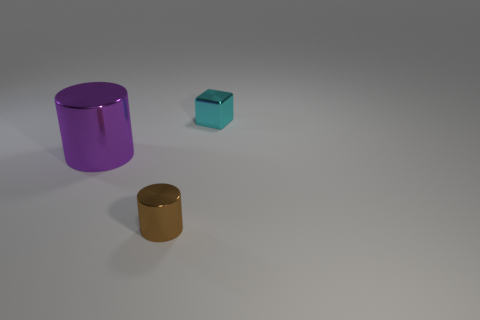What number of cyan blocks are there?
Keep it short and to the point. 1. Is the size of the block that is behind the brown cylinder the same as the small shiny cylinder?
Provide a short and direct response. Yes. What number of metallic objects are either cylinders or purple cylinders?
Provide a succinct answer. 2. How many small metal objects are to the right of the thing in front of the large object?
Provide a succinct answer. 1. There is a object that is both behind the tiny cylinder and on the right side of the large metallic object; what shape is it?
Offer a terse response. Cube. What material is the brown cylinder?
Provide a succinct answer. Metal. There is a tiny metallic object behind the object that is in front of the large purple object; what color is it?
Provide a short and direct response. Cyan. What is the size of the object that is in front of the cyan cube and behind the brown cylinder?
Ensure brevity in your answer.  Large. How many other things are there of the same shape as the large metal thing?
Your answer should be compact. 1. Is the shape of the brown object the same as the small thing behind the purple object?
Your answer should be very brief. No. 